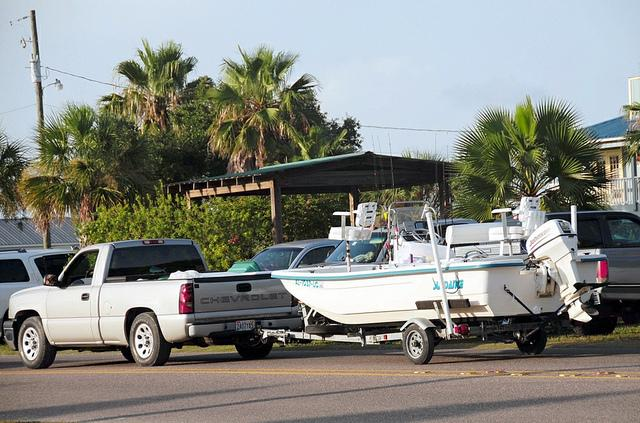What type of area is this? Please explain your reasoning. tropical. The area has palm trees which only grow in areas where it is warm year-round. 